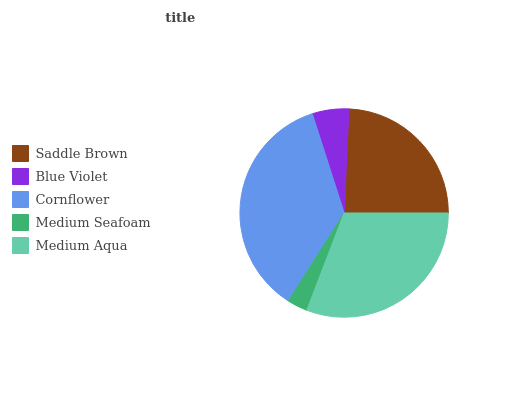Is Medium Seafoam the minimum?
Answer yes or no. Yes. Is Cornflower the maximum?
Answer yes or no. Yes. Is Blue Violet the minimum?
Answer yes or no. No. Is Blue Violet the maximum?
Answer yes or no. No. Is Saddle Brown greater than Blue Violet?
Answer yes or no. Yes. Is Blue Violet less than Saddle Brown?
Answer yes or no. Yes. Is Blue Violet greater than Saddle Brown?
Answer yes or no. No. Is Saddle Brown less than Blue Violet?
Answer yes or no. No. Is Saddle Brown the high median?
Answer yes or no. Yes. Is Saddle Brown the low median?
Answer yes or no. Yes. Is Blue Violet the high median?
Answer yes or no. No. Is Cornflower the low median?
Answer yes or no. No. 